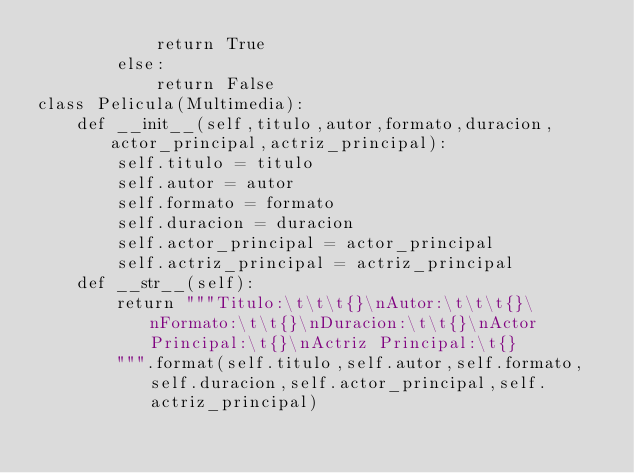Convert code to text. <code><loc_0><loc_0><loc_500><loc_500><_Python_>			return True
		else:
			return False
class Pelicula(Multimedia):
	def __init__(self,titulo,autor,formato,duracion,actor_principal,actriz_principal):
		self.titulo = titulo
		self.autor = autor
		self.formato = formato
		self.duracion = duracion
		self.actor_principal = actor_principal
		self.actriz_principal = actriz_principal
	def __str__(self):
		return """Titulo:\t\t\t{}\nAutor:\t\t\t{}\nFormato:\t\t{}\nDuracion:\t\t{}\nActor Principal:\t{}\nActriz Principal:\t{}
		""".format(self.titulo,self.autor,self.formato,self.duracion,self.actor_principal,self.actriz_principal)</code> 